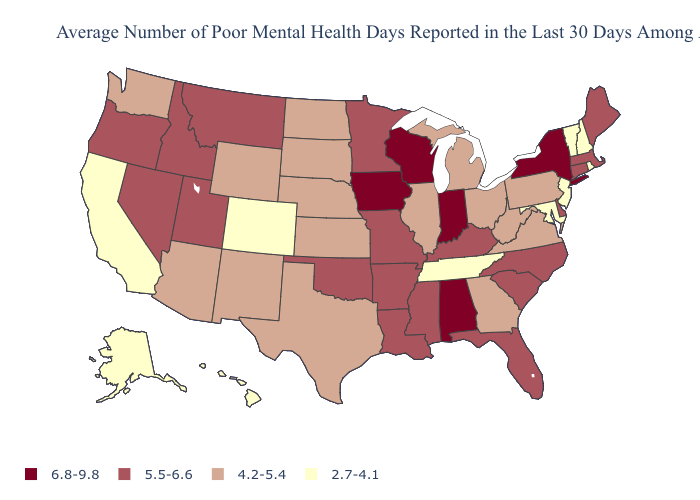Which states have the highest value in the USA?
Answer briefly. Alabama, Indiana, Iowa, New York, Wisconsin. Among the states that border South Carolina , which have the lowest value?
Concise answer only. Georgia. Among the states that border Oklahoma , does Kansas have the highest value?
Be succinct. No. Is the legend a continuous bar?
Keep it brief. No. What is the value of Utah?
Give a very brief answer. 5.5-6.6. Name the states that have a value in the range 4.2-5.4?
Short answer required. Arizona, Georgia, Illinois, Kansas, Michigan, Nebraska, New Mexico, North Dakota, Ohio, Pennsylvania, South Dakota, Texas, Virginia, Washington, West Virginia, Wyoming. Does Oklahoma have the lowest value in the USA?
Be succinct. No. Does the map have missing data?
Short answer required. No. Among the states that border New Jersey , which have the highest value?
Be succinct. New York. Name the states that have a value in the range 2.7-4.1?
Be succinct. Alaska, California, Colorado, Hawaii, Maryland, New Hampshire, New Jersey, Rhode Island, Tennessee, Vermont. What is the value of Mississippi?
Answer briefly. 5.5-6.6. Name the states that have a value in the range 5.5-6.6?
Concise answer only. Arkansas, Connecticut, Delaware, Florida, Idaho, Kentucky, Louisiana, Maine, Massachusetts, Minnesota, Mississippi, Missouri, Montana, Nevada, North Carolina, Oklahoma, Oregon, South Carolina, Utah. Which states have the lowest value in the West?
Write a very short answer. Alaska, California, Colorado, Hawaii. What is the value of Colorado?
Keep it brief. 2.7-4.1. What is the lowest value in states that border Alabama?
Answer briefly. 2.7-4.1. 